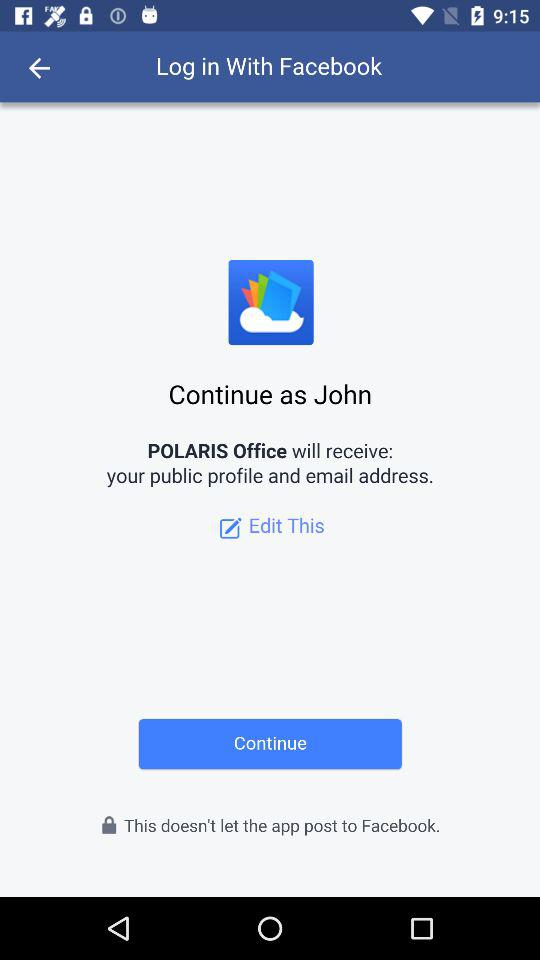Which information will "POLARIS Office" receive? "POLARIS Office" will receive your public profile and email address. 